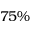Convert formula to latex. <formula><loc_0><loc_0><loc_500><loc_500>7 5 \%</formula> 